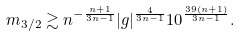<formula> <loc_0><loc_0><loc_500><loc_500>m _ { 3 / 2 } \gtrsim n ^ { - \frac { n + 1 } { 3 n - 1 } } | g | ^ { \frac { 4 } { 3 n - 1 } } 1 0 ^ { \frac { 3 9 ( n + 1 ) } { 3 n - 1 } } .</formula> 